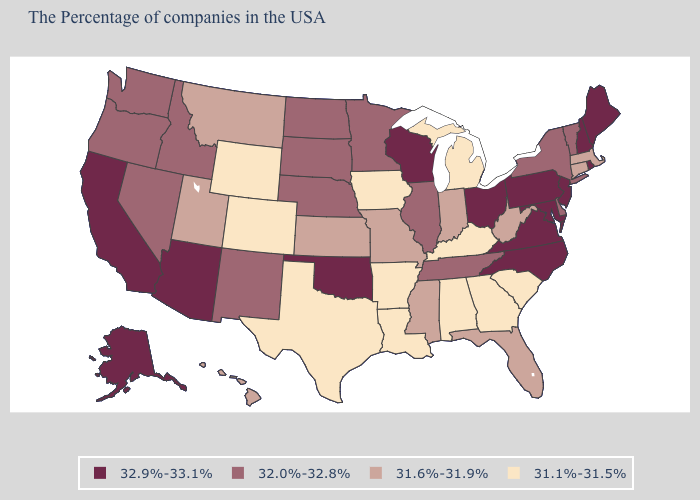Is the legend a continuous bar?
Give a very brief answer. No. Name the states that have a value in the range 32.0%-32.8%?
Keep it brief. Vermont, New York, Delaware, Tennessee, Illinois, Minnesota, Nebraska, South Dakota, North Dakota, New Mexico, Idaho, Nevada, Washington, Oregon. Is the legend a continuous bar?
Answer briefly. No. Among the states that border Texas , which have the highest value?
Be succinct. Oklahoma. Does the first symbol in the legend represent the smallest category?
Be succinct. No. Is the legend a continuous bar?
Write a very short answer. No. Name the states that have a value in the range 31.6%-31.9%?
Be succinct. Massachusetts, Connecticut, West Virginia, Florida, Indiana, Mississippi, Missouri, Kansas, Utah, Montana, Hawaii. Does South Dakota have the lowest value in the USA?
Keep it brief. No. What is the value of Rhode Island?
Keep it brief. 32.9%-33.1%. Among the states that border Connecticut , which have the highest value?
Short answer required. Rhode Island. Name the states that have a value in the range 31.6%-31.9%?
Answer briefly. Massachusetts, Connecticut, West Virginia, Florida, Indiana, Mississippi, Missouri, Kansas, Utah, Montana, Hawaii. Does the map have missing data?
Give a very brief answer. No. What is the value of Maryland?
Give a very brief answer. 32.9%-33.1%. Name the states that have a value in the range 31.1%-31.5%?
Keep it brief. South Carolina, Georgia, Michigan, Kentucky, Alabama, Louisiana, Arkansas, Iowa, Texas, Wyoming, Colorado. 